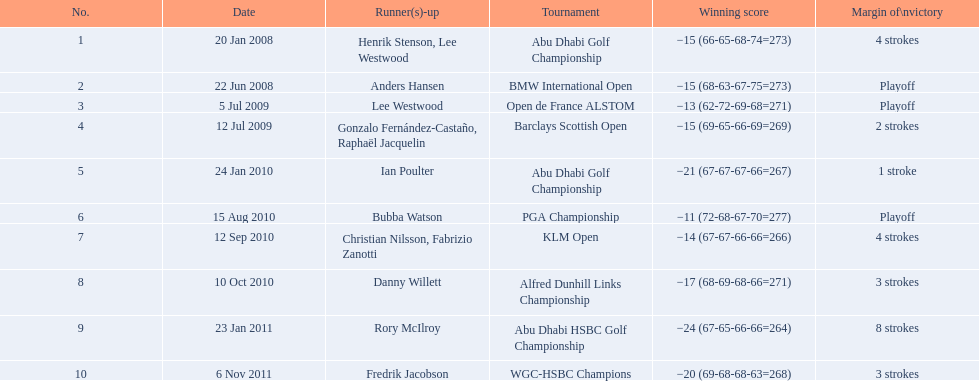What were the margins of victories of the tournaments? 4 strokes, Playoff, Playoff, 2 strokes, 1 stroke, Playoff, 4 strokes, 3 strokes, 8 strokes, 3 strokes. Of these, what was the margin of victory of the klm and the barklay 2 strokes, 4 strokes. What were the difference between these? 2 strokes. 